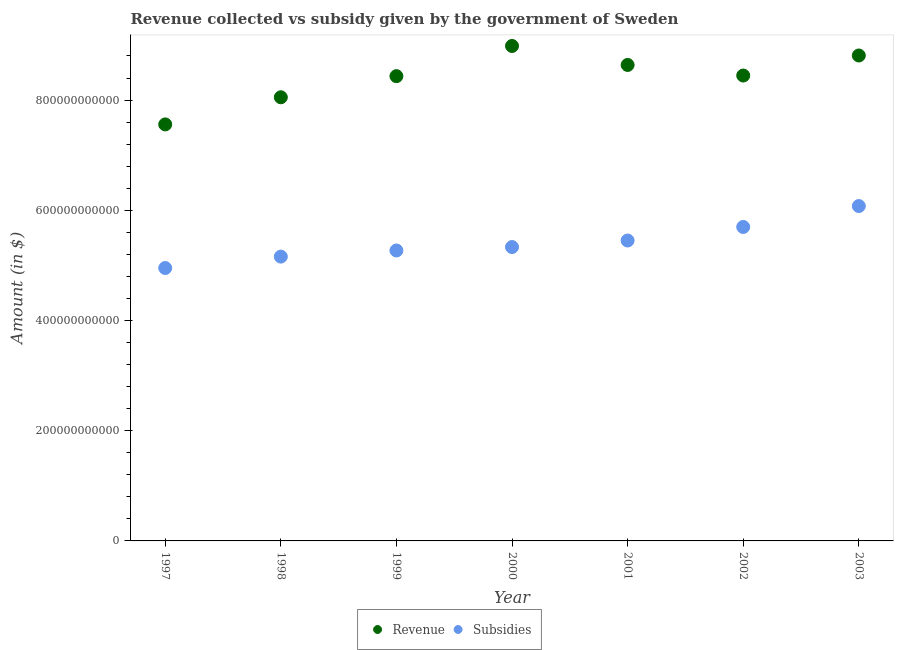Is the number of dotlines equal to the number of legend labels?
Offer a terse response. Yes. What is the amount of revenue collected in 2003?
Your answer should be very brief. 8.81e+11. Across all years, what is the maximum amount of subsidies given?
Provide a short and direct response. 6.08e+11. Across all years, what is the minimum amount of revenue collected?
Your answer should be compact. 7.56e+11. In which year was the amount of revenue collected minimum?
Ensure brevity in your answer.  1997. What is the total amount of revenue collected in the graph?
Provide a short and direct response. 5.89e+12. What is the difference between the amount of revenue collected in 1998 and that in 2003?
Offer a terse response. -7.58e+1. What is the difference between the amount of revenue collected in 1999 and the amount of subsidies given in 2000?
Give a very brief answer. 3.10e+11. What is the average amount of revenue collected per year?
Provide a short and direct response. 8.42e+11. In the year 2001, what is the difference between the amount of revenue collected and amount of subsidies given?
Offer a very short reply. 3.19e+11. What is the ratio of the amount of subsidies given in 2001 to that in 2002?
Provide a short and direct response. 0.96. What is the difference between the highest and the second highest amount of subsidies given?
Offer a terse response. 3.79e+1. What is the difference between the highest and the lowest amount of revenue collected?
Your answer should be very brief. 1.42e+11. In how many years, is the amount of subsidies given greater than the average amount of subsidies given taken over all years?
Your answer should be very brief. 3. Is the sum of the amount of revenue collected in 1999 and 2001 greater than the maximum amount of subsidies given across all years?
Make the answer very short. Yes. Does the amount of subsidies given monotonically increase over the years?
Provide a succinct answer. Yes. Is the amount of revenue collected strictly greater than the amount of subsidies given over the years?
Give a very brief answer. Yes. How many dotlines are there?
Keep it short and to the point. 2. What is the difference between two consecutive major ticks on the Y-axis?
Your answer should be compact. 2.00e+11. Does the graph contain any zero values?
Offer a terse response. No. How many legend labels are there?
Make the answer very short. 2. How are the legend labels stacked?
Your response must be concise. Horizontal. What is the title of the graph?
Your answer should be very brief. Revenue collected vs subsidy given by the government of Sweden. Does "Investments" appear as one of the legend labels in the graph?
Provide a short and direct response. No. What is the label or title of the Y-axis?
Provide a succinct answer. Amount (in $). What is the Amount (in $) in Revenue in 1997?
Give a very brief answer. 7.56e+11. What is the Amount (in $) of Subsidies in 1997?
Make the answer very short. 4.95e+11. What is the Amount (in $) in Revenue in 1998?
Ensure brevity in your answer.  8.05e+11. What is the Amount (in $) in Subsidies in 1998?
Offer a very short reply. 5.16e+11. What is the Amount (in $) in Revenue in 1999?
Offer a very short reply. 8.43e+11. What is the Amount (in $) of Subsidies in 1999?
Offer a terse response. 5.27e+11. What is the Amount (in $) in Revenue in 2000?
Make the answer very short. 8.98e+11. What is the Amount (in $) in Subsidies in 2000?
Give a very brief answer. 5.33e+11. What is the Amount (in $) of Revenue in 2001?
Ensure brevity in your answer.  8.64e+11. What is the Amount (in $) of Subsidies in 2001?
Offer a very short reply. 5.45e+11. What is the Amount (in $) in Revenue in 2002?
Your answer should be compact. 8.45e+11. What is the Amount (in $) of Subsidies in 2002?
Make the answer very short. 5.70e+11. What is the Amount (in $) in Revenue in 2003?
Your response must be concise. 8.81e+11. What is the Amount (in $) of Subsidies in 2003?
Your response must be concise. 6.08e+11. Across all years, what is the maximum Amount (in $) in Revenue?
Your answer should be compact. 8.98e+11. Across all years, what is the maximum Amount (in $) of Subsidies?
Make the answer very short. 6.08e+11. Across all years, what is the minimum Amount (in $) of Revenue?
Make the answer very short. 7.56e+11. Across all years, what is the minimum Amount (in $) of Subsidies?
Offer a very short reply. 4.95e+11. What is the total Amount (in $) of Revenue in the graph?
Offer a very short reply. 5.89e+12. What is the total Amount (in $) in Subsidies in the graph?
Give a very brief answer. 3.79e+12. What is the difference between the Amount (in $) in Revenue in 1997 and that in 1998?
Offer a very short reply. -4.92e+1. What is the difference between the Amount (in $) in Subsidies in 1997 and that in 1998?
Make the answer very short. -2.07e+1. What is the difference between the Amount (in $) in Revenue in 1997 and that in 1999?
Give a very brief answer. -8.76e+1. What is the difference between the Amount (in $) of Subsidies in 1997 and that in 1999?
Ensure brevity in your answer.  -3.18e+1. What is the difference between the Amount (in $) of Revenue in 1997 and that in 2000?
Offer a terse response. -1.42e+11. What is the difference between the Amount (in $) of Subsidies in 1997 and that in 2000?
Provide a short and direct response. -3.81e+1. What is the difference between the Amount (in $) of Revenue in 1997 and that in 2001?
Give a very brief answer. -1.08e+11. What is the difference between the Amount (in $) in Subsidies in 1997 and that in 2001?
Keep it short and to the point. -4.99e+1. What is the difference between the Amount (in $) in Revenue in 1997 and that in 2002?
Provide a short and direct response. -8.87e+1. What is the difference between the Amount (in $) in Subsidies in 1997 and that in 2002?
Make the answer very short. -7.45e+1. What is the difference between the Amount (in $) in Revenue in 1997 and that in 2003?
Your answer should be very brief. -1.25e+11. What is the difference between the Amount (in $) of Subsidies in 1997 and that in 2003?
Ensure brevity in your answer.  -1.12e+11. What is the difference between the Amount (in $) of Revenue in 1998 and that in 1999?
Make the answer very short. -3.83e+1. What is the difference between the Amount (in $) of Subsidies in 1998 and that in 1999?
Your response must be concise. -1.11e+1. What is the difference between the Amount (in $) of Revenue in 1998 and that in 2000?
Keep it short and to the point. -9.31e+1. What is the difference between the Amount (in $) of Subsidies in 1998 and that in 2000?
Keep it short and to the point. -1.74e+1. What is the difference between the Amount (in $) of Revenue in 1998 and that in 2001?
Your answer should be very brief. -5.87e+1. What is the difference between the Amount (in $) of Subsidies in 1998 and that in 2001?
Offer a very short reply. -2.92e+1. What is the difference between the Amount (in $) in Revenue in 1998 and that in 2002?
Provide a succinct answer. -3.95e+1. What is the difference between the Amount (in $) in Subsidies in 1998 and that in 2002?
Give a very brief answer. -5.38e+1. What is the difference between the Amount (in $) of Revenue in 1998 and that in 2003?
Your answer should be compact. -7.58e+1. What is the difference between the Amount (in $) of Subsidies in 1998 and that in 2003?
Provide a short and direct response. -9.17e+1. What is the difference between the Amount (in $) in Revenue in 1999 and that in 2000?
Ensure brevity in your answer.  -5.48e+1. What is the difference between the Amount (in $) in Subsidies in 1999 and that in 2000?
Ensure brevity in your answer.  -6.25e+09. What is the difference between the Amount (in $) of Revenue in 1999 and that in 2001?
Provide a short and direct response. -2.03e+1. What is the difference between the Amount (in $) of Subsidies in 1999 and that in 2001?
Keep it short and to the point. -1.81e+1. What is the difference between the Amount (in $) of Revenue in 1999 and that in 2002?
Give a very brief answer. -1.12e+09. What is the difference between the Amount (in $) in Subsidies in 1999 and that in 2002?
Provide a short and direct response. -4.27e+1. What is the difference between the Amount (in $) of Revenue in 1999 and that in 2003?
Ensure brevity in your answer.  -3.75e+1. What is the difference between the Amount (in $) of Subsidies in 1999 and that in 2003?
Keep it short and to the point. -8.06e+1. What is the difference between the Amount (in $) in Revenue in 2000 and that in 2001?
Provide a succinct answer. 3.44e+1. What is the difference between the Amount (in $) in Subsidies in 2000 and that in 2001?
Ensure brevity in your answer.  -1.18e+1. What is the difference between the Amount (in $) of Revenue in 2000 and that in 2002?
Offer a very short reply. 5.36e+1. What is the difference between the Amount (in $) in Subsidies in 2000 and that in 2002?
Provide a succinct answer. -3.64e+1. What is the difference between the Amount (in $) in Revenue in 2000 and that in 2003?
Keep it short and to the point. 1.73e+1. What is the difference between the Amount (in $) of Subsidies in 2000 and that in 2003?
Your response must be concise. -7.44e+1. What is the difference between the Amount (in $) in Revenue in 2001 and that in 2002?
Your response must be concise. 1.92e+1. What is the difference between the Amount (in $) of Subsidies in 2001 and that in 2002?
Offer a very short reply. -2.46e+1. What is the difference between the Amount (in $) of Revenue in 2001 and that in 2003?
Ensure brevity in your answer.  -1.72e+1. What is the difference between the Amount (in $) in Subsidies in 2001 and that in 2003?
Offer a terse response. -6.25e+1. What is the difference between the Amount (in $) in Revenue in 2002 and that in 2003?
Offer a terse response. -3.64e+1. What is the difference between the Amount (in $) of Subsidies in 2002 and that in 2003?
Keep it short and to the point. -3.79e+1. What is the difference between the Amount (in $) in Revenue in 1997 and the Amount (in $) in Subsidies in 1998?
Provide a succinct answer. 2.40e+11. What is the difference between the Amount (in $) in Revenue in 1997 and the Amount (in $) in Subsidies in 1999?
Make the answer very short. 2.29e+11. What is the difference between the Amount (in $) in Revenue in 1997 and the Amount (in $) in Subsidies in 2000?
Keep it short and to the point. 2.23e+11. What is the difference between the Amount (in $) of Revenue in 1997 and the Amount (in $) of Subsidies in 2001?
Your response must be concise. 2.11e+11. What is the difference between the Amount (in $) of Revenue in 1997 and the Amount (in $) of Subsidies in 2002?
Offer a terse response. 1.86e+11. What is the difference between the Amount (in $) of Revenue in 1997 and the Amount (in $) of Subsidies in 2003?
Offer a very short reply. 1.48e+11. What is the difference between the Amount (in $) of Revenue in 1998 and the Amount (in $) of Subsidies in 1999?
Provide a succinct answer. 2.78e+11. What is the difference between the Amount (in $) of Revenue in 1998 and the Amount (in $) of Subsidies in 2000?
Provide a short and direct response. 2.72e+11. What is the difference between the Amount (in $) of Revenue in 1998 and the Amount (in $) of Subsidies in 2001?
Your answer should be compact. 2.60e+11. What is the difference between the Amount (in $) of Revenue in 1998 and the Amount (in $) of Subsidies in 2002?
Your answer should be very brief. 2.35e+11. What is the difference between the Amount (in $) in Revenue in 1998 and the Amount (in $) in Subsidies in 2003?
Your response must be concise. 1.97e+11. What is the difference between the Amount (in $) in Revenue in 1999 and the Amount (in $) in Subsidies in 2000?
Provide a succinct answer. 3.10e+11. What is the difference between the Amount (in $) in Revenue in 1999 and the Amount (in $) in Subsidies in 2001?
Provide a short and direct response. 2.98e+11. What is the difference between the Amount (in $) of Revenue in 1999 and the Amount (in $) of Subsidies in 2002?
Your answer should be compact. 2.74e+11. What is the difference between the Amount (in $) in Revenue in 1999 and the Amount (in $) in Subsidies in 2003?
Give a very brief answer. 2.36e+11. What is the difference between the Amount (in $) of Revenue in 2000 and the Amount (in $) of Subsidies in 2001?
Offer a very short reply. 3.53e+11. What is the difference between the Amount (in $) of Revenue in 2000 and the Amount (in $) of Subsidies in 2002?
Provide a succinct answer. 3.28e+11. What is the difference between the Amount (in $) of Revenue in 2000 and the Amount (in $) of Subsidies in 2003?
Ensure brevity in your answer.  2.91e+11. What is the difference between the Amount (in $) of Revenue in 2001 and the Amount (in $) of Subsidies in 2002?
Offer a terse response. 2.94e+11. What is the difference between the Amount (in $) in Revenue in 2001 and the Amount (in $) in Subsidies in 2003?
Make the answer very short. 2.56e+11. What is the difference between the Amount (in $) of Revenue in 2002 and the Amount (in $) of Subsidies in 2003?
Your answer should be very brief. 2.37e+11. What is the average Amount (in $) in Revenue per year?
Offer a terse response. 8.42e+11. What is the average Amount (in $) in Subsidies per year?
Offer a very short reply. 5.42e+11. In the year 1997, what is the difference between the Amount (in $) of Revenue and Amount (in $) of Subsidies?
Ensure brevity in your answer.  2.61e+11. In the year 1998, what is the difference between the Amount (in $) in Revenue and Amount (in $) in Subsidies?
Provide a succinct answer. 2.89e+11. In the year 1999, what is the difference between the Amount (in $) of Revenue and Amount (in $) of Subsidies?
Keep it short and to the point. 3.16e+11. In the year 2000, what is the difference between the Amount (in $) of Revenue and Amount (in $) of Subsidies?
Offer a very short reply. 3.65e+11. In the year 2001, what is the difference between the Amount (in $) of Revenue and Amount (in $) of Subsidies?
Keep it short and to the point. 3.19e+11. In the year 2002, what is the difference between the Amount (in $) of Revenue and Amount (in $) of Subsidies?
Your response must be concise. 2.75e+11. In the year 2003, what is the difference between the Amount (in $) of Revenue and Amount (in $) of Subsidies?
Make the answer very short. 2.73e+11. What is the ratio of the Amount (in $) in Revenue in 1997 to that in 1998?
Provide a short and direct response. 0.94. What is the ratio of the Amount (in $) in Subsidies in 1997 to that in 1998?
Provide a succinct answer. 0.96. What is the ratio of the Amount (in $) of Revenue in 1997 to that in 1999?
Make the answer very short. 0.9. What is the ratio of the Amount (in $) in Subsidies in 1997 to that in 1999?
Make the answer very short. 0.94. What is the ratio of the Amount (in $) in Revenue in 1997 to that in 2000?
Make the answer very short. 0.84. What is the ratio of the Amount (in $) in Revenue in 1997 to that in 2001?
Give a very brief answer. 0.88. What is the ratio of the Amount (in $) of Subsidies in 1997 to that in 2001?
Offer a very short reply. 0.91. What is the ratio of the Amount (in $) in Revenue in 1997 to that in 2002?
Offer a very short reply. 0.9. What is the ratio of the Amount (in $) of Subsidies in 1997 to that in 2002?
Your answer should be very brief. 0.87. What is the ratio of the Amount (in $) of Revenue in 1997 to that in 2003?
Provide a succinct answer. 0.86. What is the ratio of the Amount (in $) of Subsidies in 1997 to that in 2003?
Offer a terse response. 0.81. What is the ratio of the Amount (in $) in Revenue in 1998 to that in 1999?
Offer a terse response. 0.95. What is the ratio of the Amount (in $) of Subsidies in 1998 to that in 1999?
Give a very brief answer. 0.98. What is the ratio of the Amount (in $) in Revenue in 1998 to that in 2000?
Give a very brief answer. 0.9. What is the ratio of the Amount (in $) in Subsidies in 1998 to that in 2000?
Provide a succinct answer. 0.97. What is the ratio of the Amount (in $) of Revenue in 1998 to that in 2001?
Ensure brevity in your answer.  0.93. What is the ratio of the Amount (in $) in Subsidies in 1998 to that in 2001?
Make the answer very short. 0.95. What is the ratio of the Amount (in $) in Revenue in 1998 to that in 2002?
Give a very brief answer. 0.95. What is the ratio of the Amount (in $) in Subsidies in 1998 to that in 2002?
Your response must be concise. 0.91. What is the ratio of the Amount (in $) in Revenue in 1998 to that in 2003?
Keep it short and to the point. 0.91. What is the ratio of the Amount (in $) in Subsidies in 1998 to that in 2003?
Your answer should be very brief. 0.85. What is the ratio of the Amount (in $) in Revenue in 1999 to that in 2000?
Keep it short and to the point. 0.94. What is the ratio of the Amount (in $) in Subsidies in 1999 to that in 2000?
Offer a terse response. 0.99. What is the ratio of the Amount (in $) of Revenue in 1999 to that in 2001?
Give a very brief answer. 0.98. What is the ratio of the Amount (in $) in Subsidies in 1999 to that in 2001?
Keep it short and to the point. 0.97. What is the ratio of the Amount (in $) in Subsidies in 1999 to that in 2002?
Offer a terse response. 0.93. What is the ratio of the Amount (in $) in Revenue in 1999 to that in 2003?
Provide a short and direct response. 0.96. What is the ratio of the Amount (in $) in Subsidies in 1999 to that in 2003?
Ensure brevity in your answer.  0.87. What is the ratio of the Amount (in $) in Revenue in 2000 to that in 2001?
Your answer should be compact. 1.04. What is the ratio of the Amount (in $) of Subsidies in 2000 to that in 2001?
Ensure brevity in your answer.  0.98. What is the ratio of the Amount (in $) of Revenue in 2000 to that in 2002?
Your answer should be very brief. 1.06. What is the ratio of the Amount (in $) in Subsidies in 2000 to that in 2002?
Provide a short and direct response. 0.94. What is the ratio of the Amount (in $) in Revenue in 2000 to that in 2003?
Your answer should be very brief. 1.02. What is the ratio of the Amount (in $) in Subsidies in 2000 to that in 2003?
Offer a very short reply. 0.88. What is the ratio of the Amount (in $) in Revenue in 2001 to that in 2002?
Ensure brevity in your answer.  1.02. What is the ratio of the Amount (in $) of Subsidies in 2001 to that in 2002?
Offer a very short reply. 0.96. What is the ratio of the Amount (in $) in Revenue in 2001 to that in 2003?
Make the answer very short. 0.98. What is the ratio of the Amount (in $) in Subsidies in 2001 to that in 2003?
Your answer should be very brief. 0.9. What is the ratio of the Amount (in $) in Revenue in 2002 to that in 2003?
Ensure brevity in your answer.  0.96. What is the ratio of the Amount (in $) in Subsidies in 2002 to that in 2003?
Keep it short and to the point. 0.94. What is the difference between the highest and the second highest Amount (in $) of Revenue?
Your answer should be compact. 1.73e+1. What is the difference between the highest and the second highest Amount (in $) of Subsidies?
Your answer should be compact. 3.79e+1. What is the difference between the highest and the lowest Amount (in $) in Revenue?
Keep it short and to the point. 1.42e+11. What is the difference between the highest and the lowest Amount (in $) of Subsidies?
Offer a very short reply. 1.12e+11. 